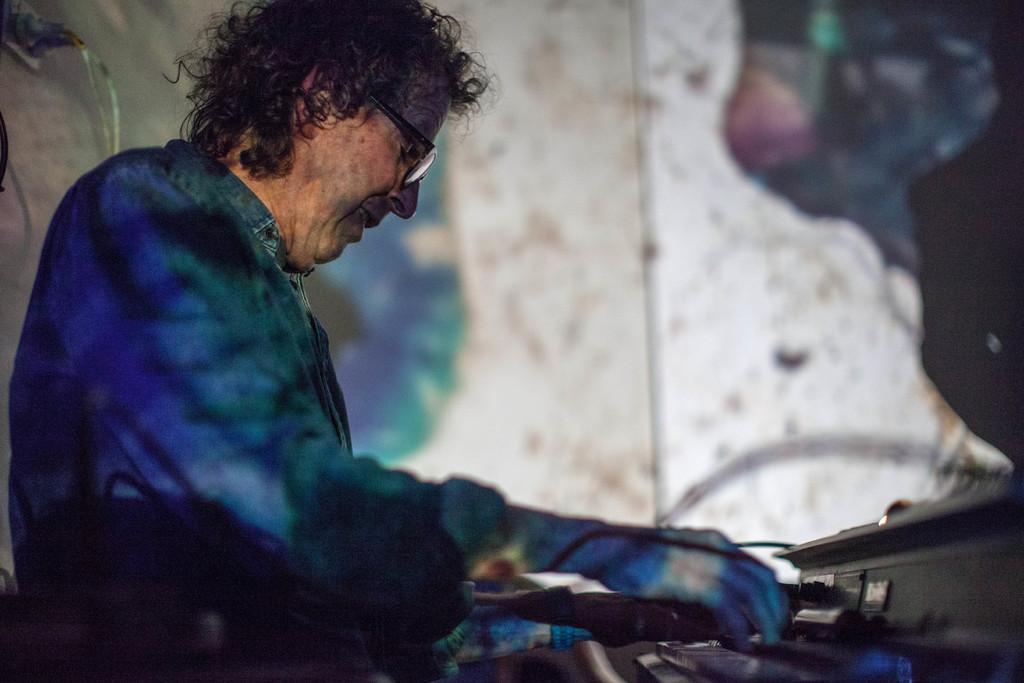Describe this image in one or two sentences. In this image I can see the person with the blue color dress and wearing the specs. He is in-front of the musical instrument. In the background I can see the wall. 